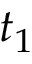Convert formula to latex. <formula><loc_0><loc_0><loc_500><loc_500>t _ { 1 }</formula> 